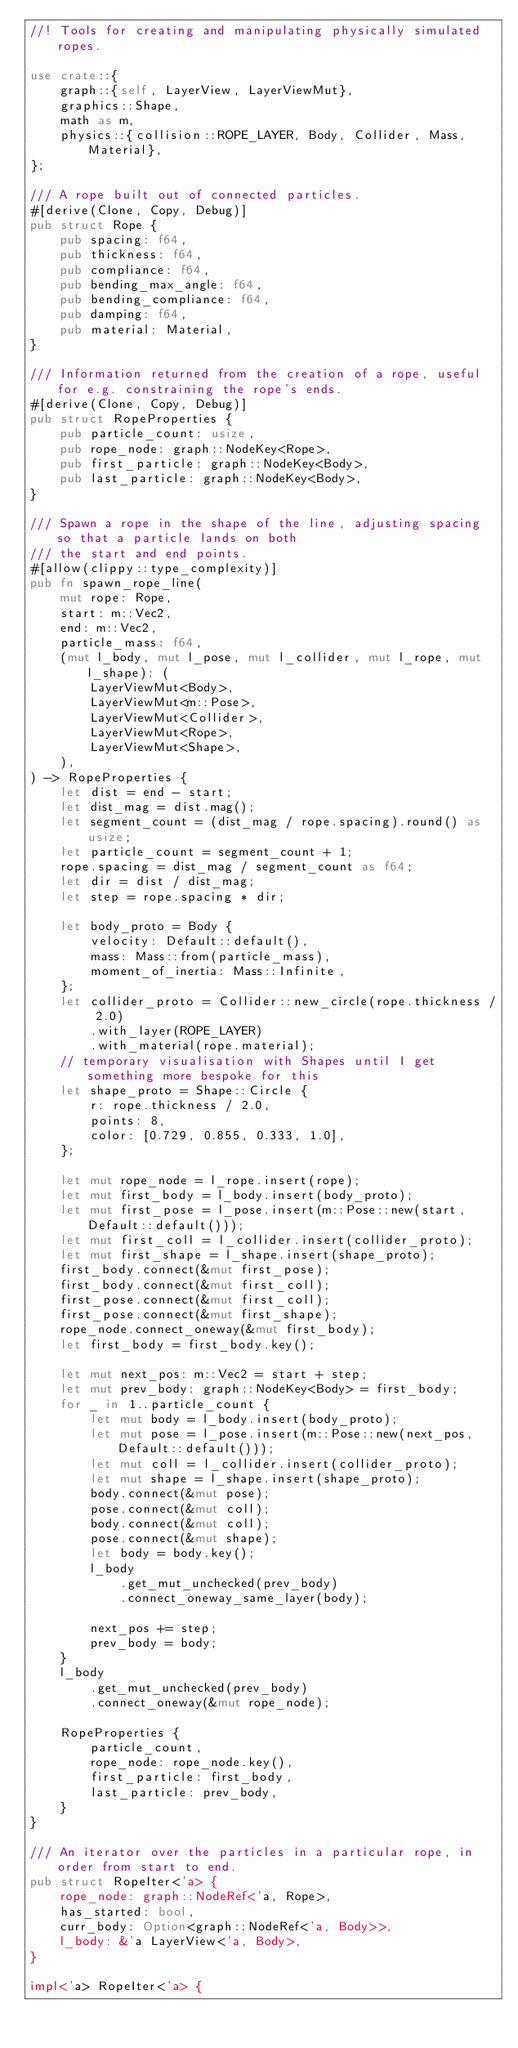Convert code to text. <code><loc_0><loc_0><loc_500><loc_500><_Rust_>//! Tools for creating and manipulating physically simulated ropes.

use crate::{
    graph::{self, LayerView, LayerViewMut},
    graphics::Shape,
    math as m,
    physics::{collision::ROPE_LAYER, Body, Collider, Mass, Material},
};

/// A rope built out of connected particles.
#[derive(Clone, Copy, Debug)]
pub struct Rope {
    pub spacing: f64,
    pub thickness: f64,
    pub compliance: f64,
    pub bending_max_angle: f64,
    pub bending_compliance: f64,
    pub damping: f64,
    pub material: Material,
}

/// Information returned from the creation of a rope, useful for e.g. constraining the rope's ends.
#[derive(Clone, Copy, Debug)]
pub struct RopeProperties {
    pub particle_count: usize,
    pub rope_node: graph::NodeKey<Rope>,
    pub first_particle: graph::NodeKey<Body>,
    pub last_particle: graph::NodeKey<Body>,
}

/// Spawn a rope in the shape of the line, adjusting spacing so that a particle lands on both
/// the start and end points.
#[allow(clippy::type_complexity)]
pub fn spawn_rope_line(
    mut rope: Rope,
    start: m::Vec2,
    end: m::Vec2,
    particle_mass: f64,
    (mut l_body, mut l_pose, mut l_collider, mut l_rope, mut l_shape): (
        LayerViewMut<Body>,
        LayerViewMut<m::Pose>,
        LayerViewMut<Collider>,
        LayerViewMut<Rope>,
        LayerViewMut<Shape>,
    ),
) -> RopeProperties {
    let dist = end - start;
    let dist_mag = dist.mag();
    let segment_count = (dist_mag / rope.spacing).round() as usize;
    let particle_count = segment_count + 1;
    rope.spacing = dist_mag / segment_count as f64;
    let dir = dist / dist_mag;
    let step = rope.spacing * dir;

    let body_proto = Body {
        velocity: Default::default(),
        mass: Mass::from(particle_mass),
        moment_of_inertia: Mass::Infinite,
    };
    let collider_proto = Collider::new_circle(rope.thickness / 2.0)
        .with_layer(ROPE_LAYER)
        .with_material(rope.material);
    // temporary visualisation with Shapes until I get something more bespoke for this
    let shape_proto = Shape::Circle {
        r: rope.thickness / 2.0,
        points: 8,
        color: [0.729, 0.855, 0.333, 1.0],
    };

    let mut rope_node = l_rope.insert(rope);
    let mut first_body = l_body.insert(body_proto);
    let mut first_pose = l_pose.insert(m::Pose::new(start, Default::default()));
    let mut first_coll = l_collider.insert(collider_proto);
    let mut first_shape = l_shape.insert(shape_proto);
    first_body.connect(&mut first_pose);
    first_body.connect(&mut first_coll);
    first_pose.connect(&mut first_coll);
    first_pose.connect(&mut first_shape);
    rope_node.connect_oneway(&mut first_body);
    let first_body = first_body.key();

    let mut next_pos: m::Vec2 = start + step;
    let mut prev_body: graph::NodeKey<Body> = first_body;
    for _ in 1..particle_count {
        let mut body = l_body.insert(body_proto);
        let mut pose = l_pose.insert(m::Pose::new(next_pos, Default::default()));
        let mut coll = l_collider.insert(collider_proto);
        let mut shape = l_shape.insert(shape_proto);
        body.connect(&mut pose);
        pose.connect(&mut coll);
        body.connect(&mut coll);
        pose.connect(&mut shape);
        let body = body.key();
        l_body
            .get_mut_unchecked(prev_body)
            .connect_oneway_same_layer(body);

        next_pos += step;
        prev_body = body;
    }
    l_body
        .get_mut_unchecked(prev_body)
        .connect_oneway(&mut rope_node);

    RopeProperties {
        particle_count,
        rope_node: rope_node.key(),
        first_particle: first_body,
        last_particle: prev_body,
    }
}

/// An iterator over the particles in a particular rope, in order from start to end.
pub struct RopeIter<'a> {
    rope_node: graph::NodeRef<'a, Rope>,
    has_started: bool,
    curr_body: Option<graph::NodeRef<'a, Body>>,
    l_body: &'a LayerView<'a, Body>,
}

impl<'a> RopeIter<'a> {</code> 